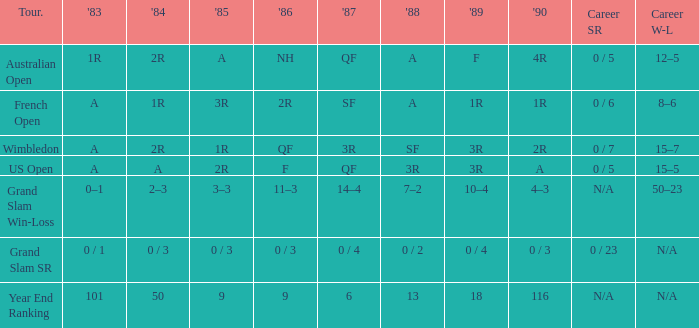In 1983 what is the tournament that is 0 / 1? Grand Slam SR. 